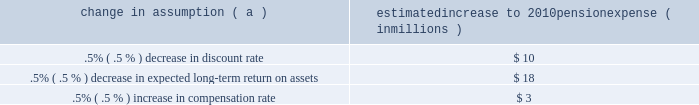Investment policy , which is described more fully in note 15 employee benefit plans in the notes to consolidated financial statements in item 8 of this report .
We calculate the expense associated with the pension plan and the assumptions and methods that we use include a policy of reflecting trust assets at their fair market value .
On an annual basis , we review the actuarial assumptions related to the pension plan , including the discount rate , the rate of compensation increase and the expected return on plan assets .
The discount rate and compensation increase assumptions do not significantly affect pension expense .
However , the expected long-term return on assets assumption does significantly affect pension expense .
Our expected long- term return on plan assets for determining net periodic pension expense has been 8.25% ( 8.25 % ) for the past three years .
The expected return on plan assets is a long-term assumption established by considering historical and anticipated returns of the asset classes invested in by the pension plan and the allocation strategy currently in place among those classes .
While this analysis gives appropriate consideration to recent asset performance and historical returns , the assumption represents a long-term prospective return .
We review this assumption at each measurement date and adjust it if warranted .
For purposes of setting and reviewing this assumption , 201clong- term 201d refers to the period over which the plan 2019s projected benefit obligation will be disbursed .
While year-to-year annual returns can vary significantly ( rates of return for the reporting years of 2009 , 2008 , and 2007 were +20.61% ( +20.61 % ) , -32.91% ( -32.91 % ) , and +7.57% ( +7.57 % ) , respectively ) , the assumption represents our estimate of long-term average prospective returns .
Our selection process references certain historical data and the current environment , but primarily utilizes qualitative judgment regarding future return expectations .
Recent annual returns may differ but , recognizing the volatility and unpredictability of investment returns , we generally do not change the assumption unless we modify our investment strategy or identify events that would alter our expectations of future returns .
To evaluate the continued reasonableness of our assumption , we examine a variety of viewpoints and data .
Various studies have shown that portfolios comprised primarily of us equity securities have returned approximately 10% ( 10 % ) over long periods of time , while us debt securities have returned approximately 6% ( 6 % ) annually over long periods .
Application of these historical returns to the plan 2019s allocation of equities and bonds produces a result between 8% ( 8 % ) and 8.5% ( 8.5 % ) and is one point of reference , among many other factors , that is taken into consideration .
We also examine the plan 2019s actual historical returns over various periods .
Recent experience is considered in our evaluation with appropriate consideration that , especially for short time periods , recent returns are not reliable indicators of future returns , and in many cases low returns in recent time periods are followed by higher returns in future periods ( and vice versa ) .
Acknowledging the potentially wide range for this assumption , we also annually examine the assumption used by other companies with similar pension investment strategies , so that we can ascertain whether our determinations markedly differ from other observers .
In all cases , however , this data simply informs our process , which places the greatest emphasis on our qualitative judgment of future investment returns , given the conditions existing at each annual measurement date .
The expected long-term return on plan assets for determining net periodic pension cost for 2009 was 8.25% ( 8.25 % ) , unchanged from 2008 .
During 2010 , we intend to decrease the midpoint of the plan 2019s target allocation range for equities by approximately five percentage points .
As a result of this change and taking into account all other factors described above , pnc will change the expected long-term return on plan assets to 8.00% ( 8.00 % ) for determining net periodic pension cost for 2010 .
Under current accounting rules , the difference between expected long-term returns and actual returns is accumulated and amortized to pension expense over future periods .
Each one percentage point difference in actual return compared with our expected return causes expense in subsequent years to change by up to $ 8 million as the impact is amortized into results of operations .
The table below reflects the estimated effects on pension expense of certain changes in annual assumptions , using 2010 estimated expense as a baseline .
Change in assumption ( a ) estimated increase to 2010 pension expense ( in millions ) .
( a ) the impact is the effect of changing the specified assumption while holding all other assumptions constant .
We currently estimate a pretax pension expense of $ 41 million in 2010 compared with pretax expense of $ 117 million in 2009 .
This year-over-year reduction was primarily due to the amortization impact of the favorable 2009 investment returns as compared with the expected long-term return assumption .
Our pension plan contribution requirements are not particularly sensitive to actuarial assumptions .
Investment performance has the most impact on contribution requirements and will drive the amount of permitted contributions in future years .
Also , current law , including the provisions of the pension protection act of 2006 , sets limits as to both minimum and maximum contributions to the plan .
We expect that the minimum required contributions under the law will be zero for 2010 .
We maintain other defined benefit plans that have a less significant effect on financial results , including various .
Does a .5% ( .5 % ) decrease in discount rate have a greater impact than a .5% ( .5 % ) decrease in expected long-term return on assets? 
Computations: (10 > 18)
Answer: no. 